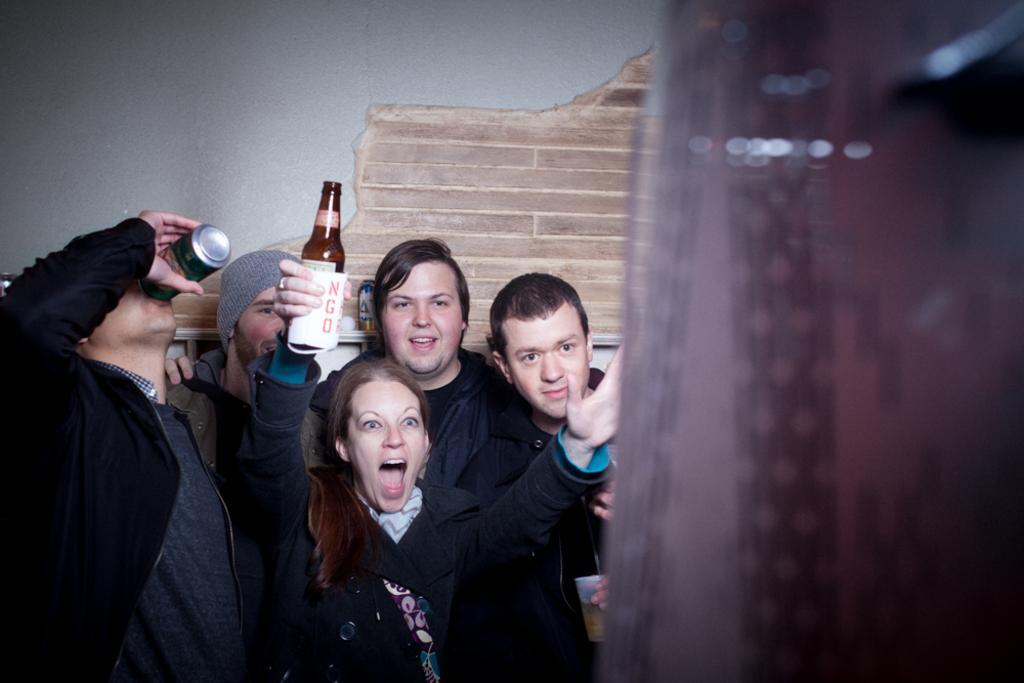Can you describe this image briefly? In this image we can see a group of people. In that a woman is holding a glass, a man is holding a tin and the other is holding a glass. On the right side we can see an object. On the backside we can see a wall. 